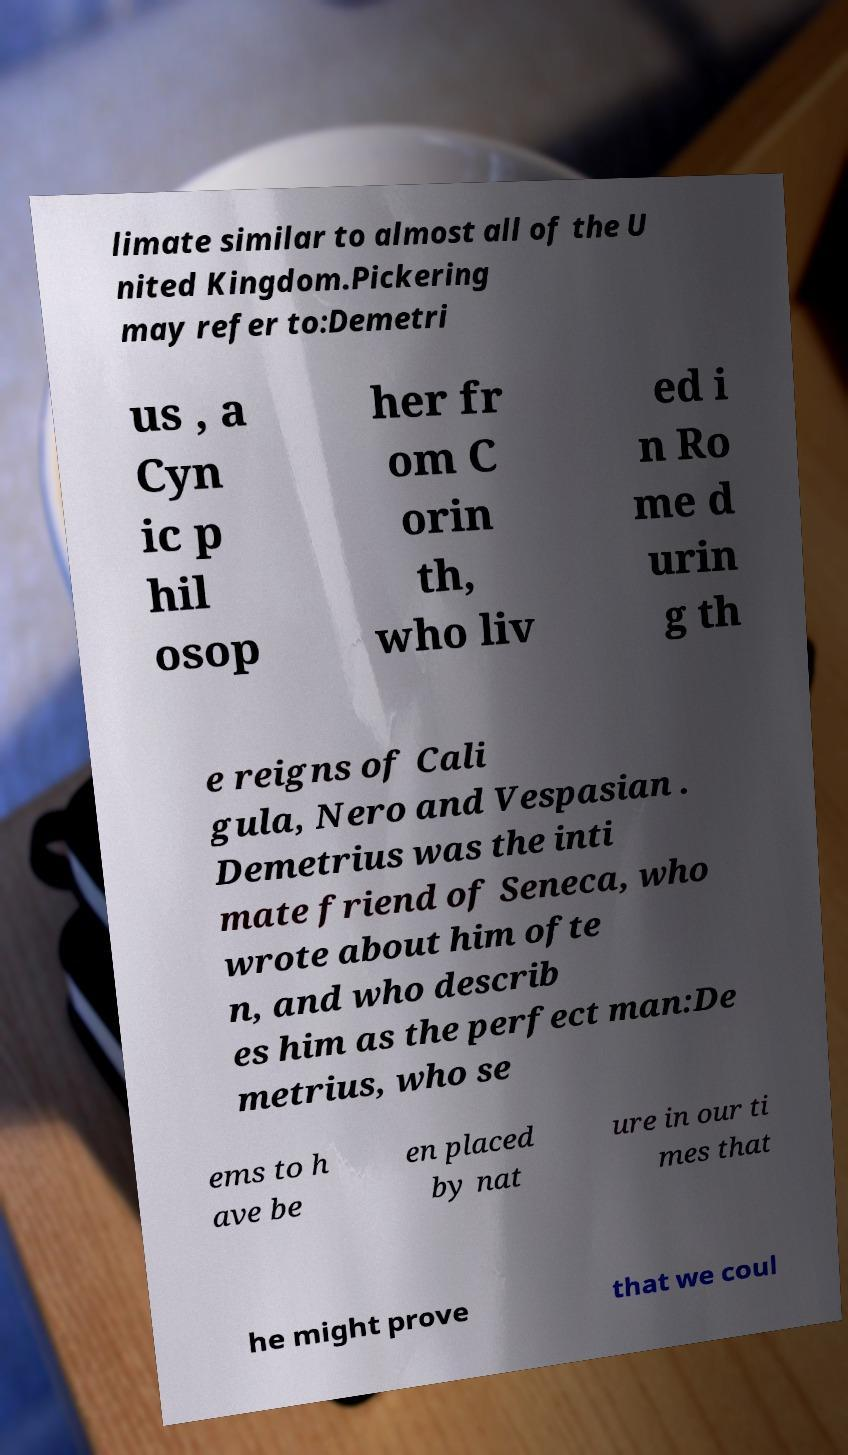For documentation purposes, I need the text within this image transcribed. Could you provide that? limate similar to almost all of the U nited Kingdom.Pickering may refer to:Demetri us , a Cyn ic p hil osop her fr om C orin th, who liv ed i n Ro me d urin g th e reigns of Cali gula, Nero and Vespasian . Demetrius was the inti mate friend of Seneca, who wrote about him ofte n, and who describ es him as the perfect man:De metrius, who se ems to h ave be en placed by nat ure in our ti mes that he might prove that we coul 